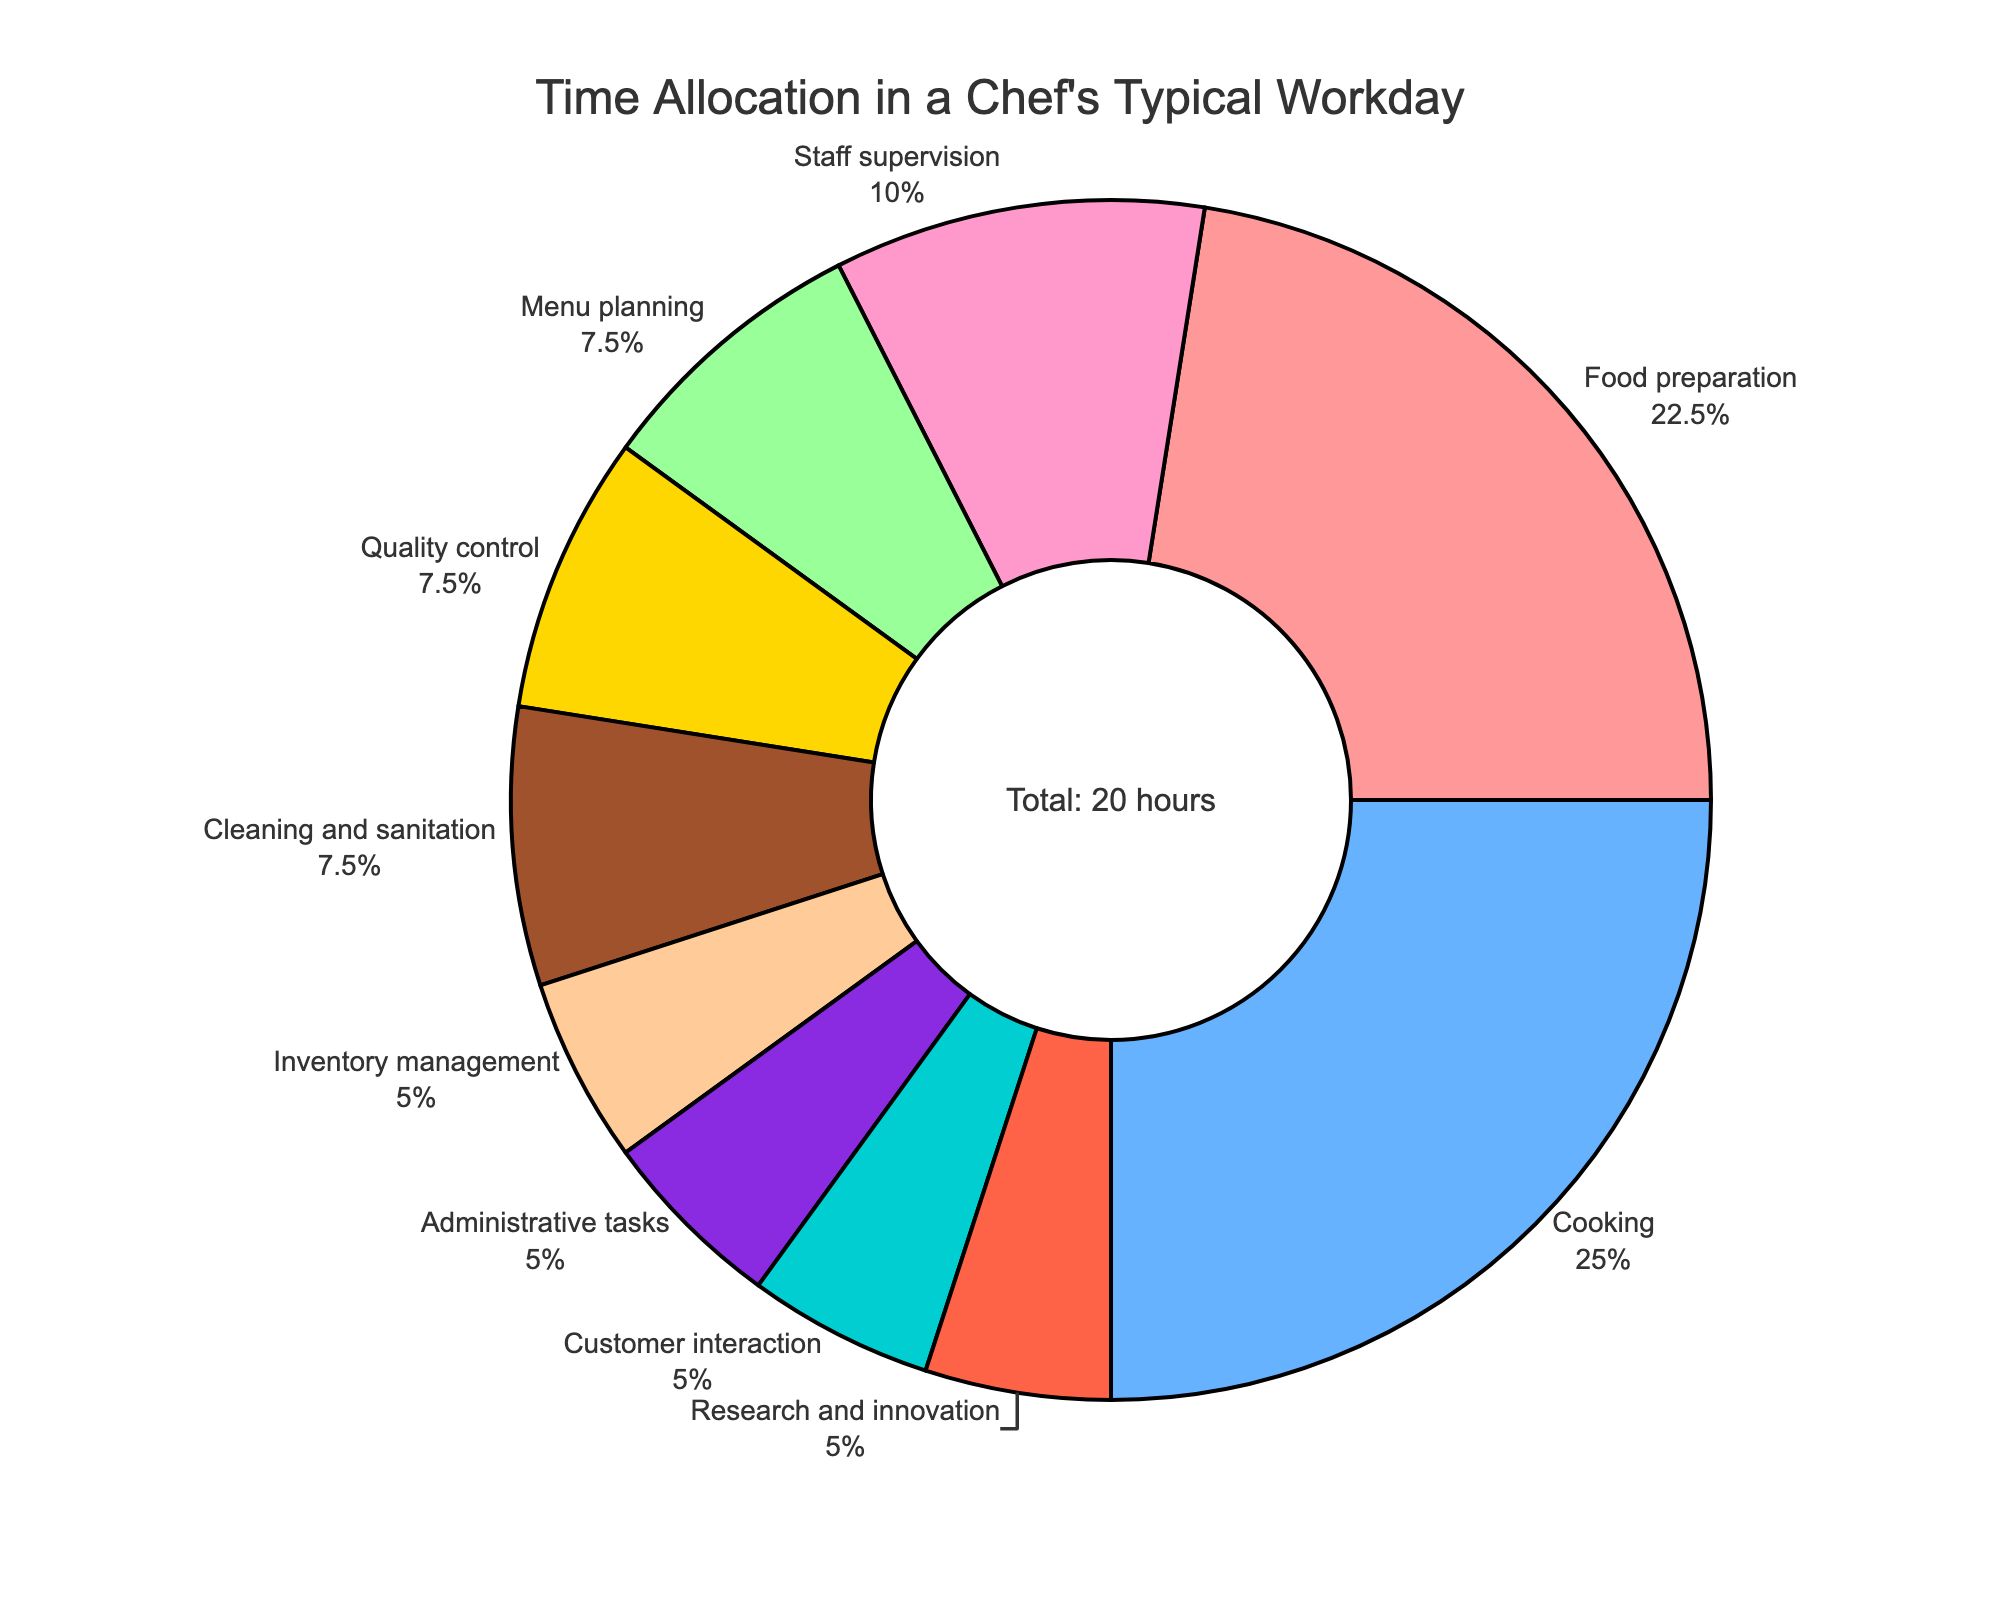Which task takes up the most time in a professional chef's typical workday? The pie chart shows that the largest section is for Cooking, indicating it takes up the most time.
Answer: Cooking How much more time is spent on Food preparation compared to Menu planning? Food preparation takes 4.5 hours and Menu planning takes 1.5 hours. The difference is 4.5 - 1.5 = 3 hours.
Answer: 3 hours What percentage of the overall time is dedicated to Staff supervision? From the pie chart, the segment labeled "Staff supervision" shows its percentage.
Answer: 10% Which task is allocated the least amount of time? The smallest segment in the pie chart represents the task with the least allocated time, which is Inventory management.
Answer: Inventory management How does the time spent on Research and Innovation compare to that on Quality control? Both tasks are represented by equal-sized segments in the pie chart, indicating that the time spent on each is the same.
Answer: Equal What fraction of the day is spent on Cleaning and sanitation? Cleaning and sanitation takes 1.5 hours out of the total 20 hours. The fraction is 1.5/20.
Answer: 1.5/20 or 0.075 If the time for Administrative tasks were increased by 1 hour, how would that affect the total time? The current time for Administrative tasks is 1 hour. Increasing it by 1 hour makes it 2 hours. The new total time is 21 hours.
Answer: 21 hours Summing up the hours spent on Food preparation and Cooking, what fraction of the total workday do they jointly cover? Food preparation and Cooking together take 4.5 + 5 = 9.5 hours. The fraction of the total 20-hour workday is 9.5/20.
Answer: 9.5/20 or 0.475 How does the time spent on Customer interaction and Research and Innovation combined compare to the time spent on Inventory management? Customer interaction and Research and Innovation together take 1 + 1 = 2 hours, which is more than the 1 hour allocated to Inventory management.
Answer: More 